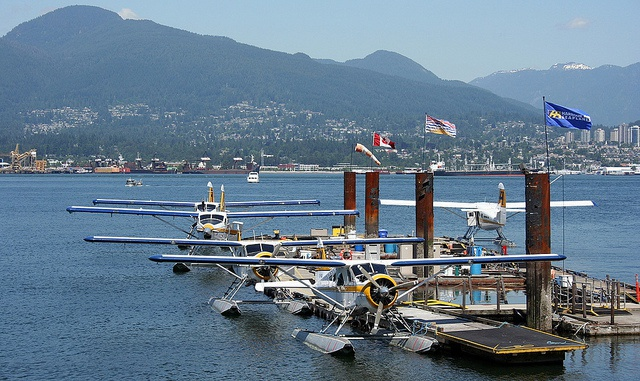Describe the objects in this image and their specific colors. I can see airplane in lightblue, black, gray, darkgray, and lightgray tones, airplane in lightblue, white, gray, and darkgray tones, airplane in lightblue, black, white, and gray tones, airplane in lightblue, white, black, gray, and darkgray tones, and airplane in lightblue, gray, white, and blue tones in this image. 